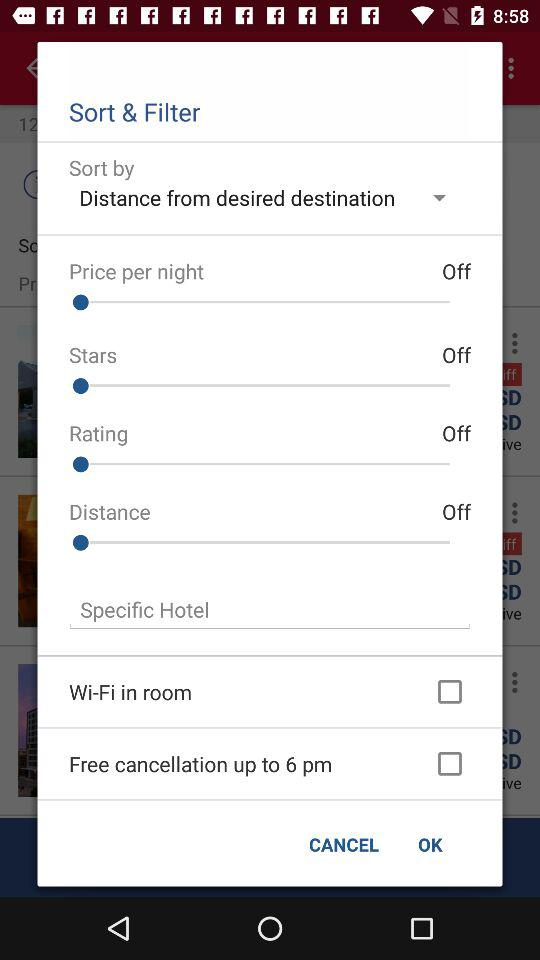What is the status of "Stars"? The status is "off". 